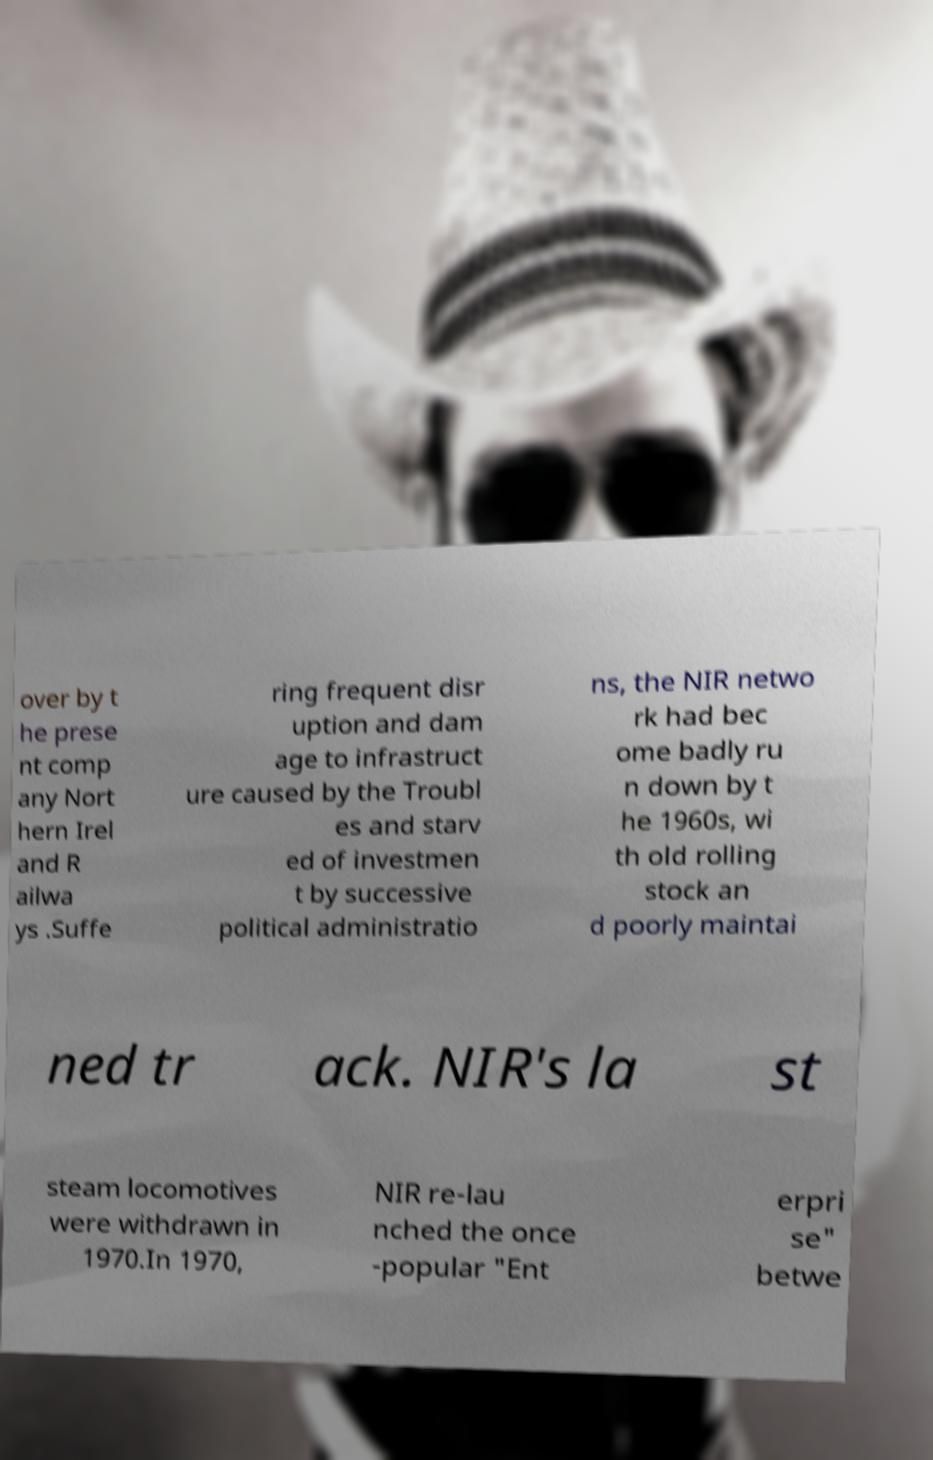Can you accurately transcribe the text from the provided image for me? over by t he prese nt comp any Nort hern Irel and R ailwa ys .Suffe ring frequent disr uption and dam age to infrastruct ure caused by the Troubl es and starv ed of investmen t by successive political administratio ns, the NIR netwo rk had bec ome badly ru n down by t he 1960s, wi th old rolling stock an d poorly maintai ned tr ack. NIR's la st steam locomotives were withdrawn in 1970.In 1970, NIR re-lau nched the once -popular "Ent erpri se" betwe 